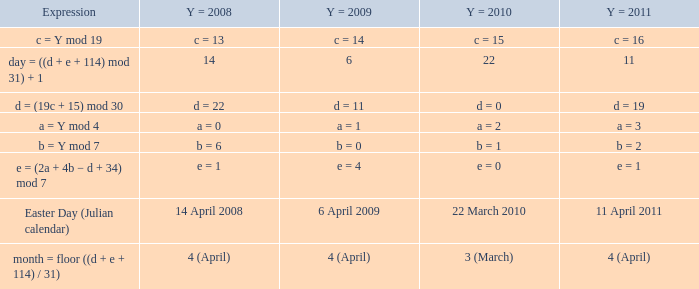I'm looking to parse the entire table for insights. Could you assist me with that? {'header': ['Expression', 'Y = 2008', 'Y = 2009', 'Y = 2010', 'Y = 2011'], 'rows': [['c = Y mod 19', 'c = 13', 'c = 14', 'c = 15', 'c = 16'], ['day = ((d + e + 114) mod 31) + 1', '14', '6', '22', '11'], ['d = (19c + 15) mod 30', 'd = 22', 'd = 11', 'd = 0', 'd = 19'], ['a = Y mod 4', 'a = 0', 'a = 1', 'a = 2', 'a = 3'], ['b = Y mod 7', 'b = 6', 'b = 0', 'b = 1', 'b = 2'], ['e = (2a + 4b − d + 34) mod 7', 'e = 1', 'e = 4', 'e = 0', 'e = 1'], ['Easter Day (Julian calendar)', '14 April 2008', '6 April 2009', '22 March 2010', '11 April 2011'], ['month = floor ((d + e + 114) / 31)', '4 (April)', '4 (April)', '3 (March)', '4 (April)']]} What is the y = 2011 when the expression is month = floor ((d + e + 114) / 31)? 4 (April). 